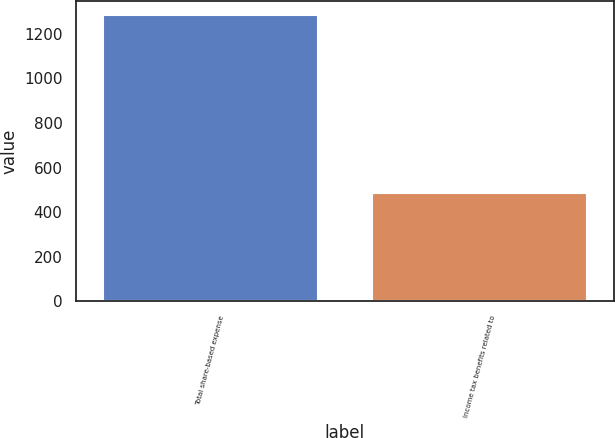<chart> <loc_0><loc_0><loc_500><loc_500><bar_chart><fcel>Total share-based expense<fcel>Income tax benefits related to<nl><fcel>1282<fcel>487<nl></chart> 